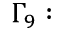Convert formula to latex. <formula><loc_0><loc_0><loc_500><loc_500>\Gamma _ { 9 } \colon</formula> 